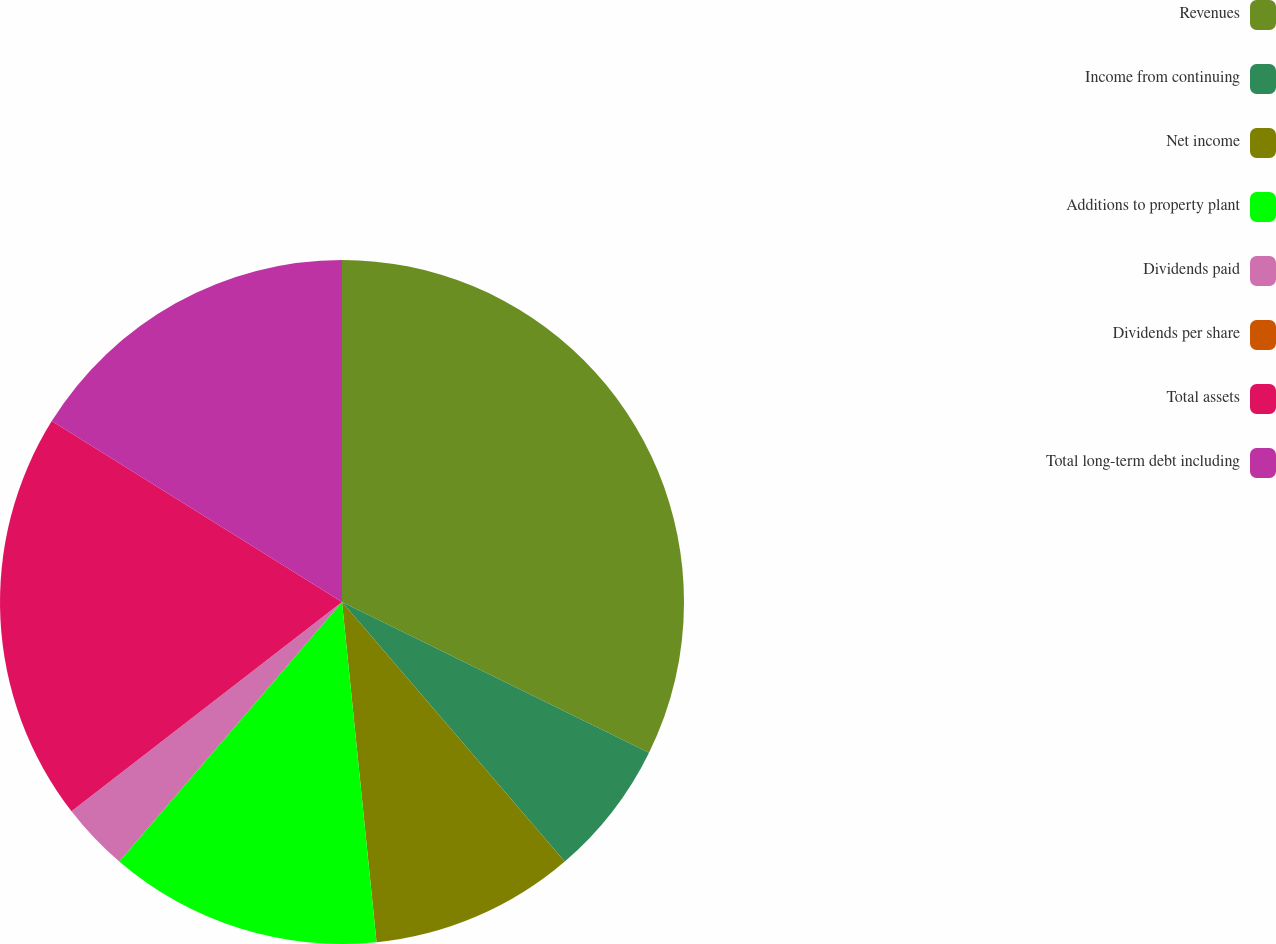Convert chart. <chart><loc_0><loc_0><loc_500><loc_500><pie_chart><fcel>Revenues<fcel>Income from continuing<fcel>Net income<fcel>Additions to property plant<fcel>Dividends paid<fcel>Dividends per share<fcel>Total assets<fcel>Total long-term debt including<nl><fcel>32.26%<fcel>6.45%<fcel>9.68%<fcel>12.9%<fcel>3.23%<fcel>0.0%<fcel>19.35%<fcel>16.13%<nl></chart> 